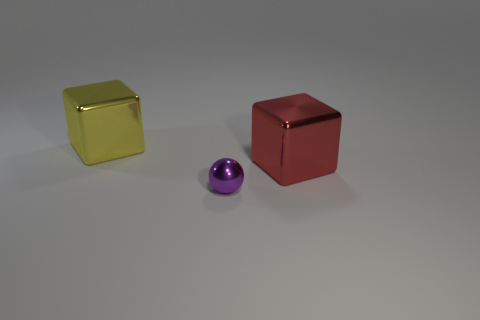The other thing that is the same shape as the yellow shiny object is what size?
Provide a succinct answer. Large. Are there an equal number of large yellow shiny blocks left of the yellow object and large yellow blocks?
Make the answer very short. No. Does the purple metallic sphere in front of the yellow metallic thing have the same size as the big red metal object?
Your answer should be very brief. No. There is a small metallic object; what number of cubes are to the right of it?
Make the answer very short. 1. What material is the thing that is both behind the tiny shiny ball and on the right side of the big yellow shiny object?
Ensure brevity in your answer.  Metal. What number of big things are brown rubber cubes or yellow objects?
Your answer should be compact. 1. The yellow cube has what size?
Provide a succinct answer. Large. There is a large red object; what shape is it?
Provide a short and direct response. Cube. Are there any other things that are the same shape as the tiny metal thing?
Provide a succinct answer. No. Is the number of large yellow blocks that are left of the tiny purple shiny thing less than the number of shiny cylinders?
Give a very brief answer. No. 